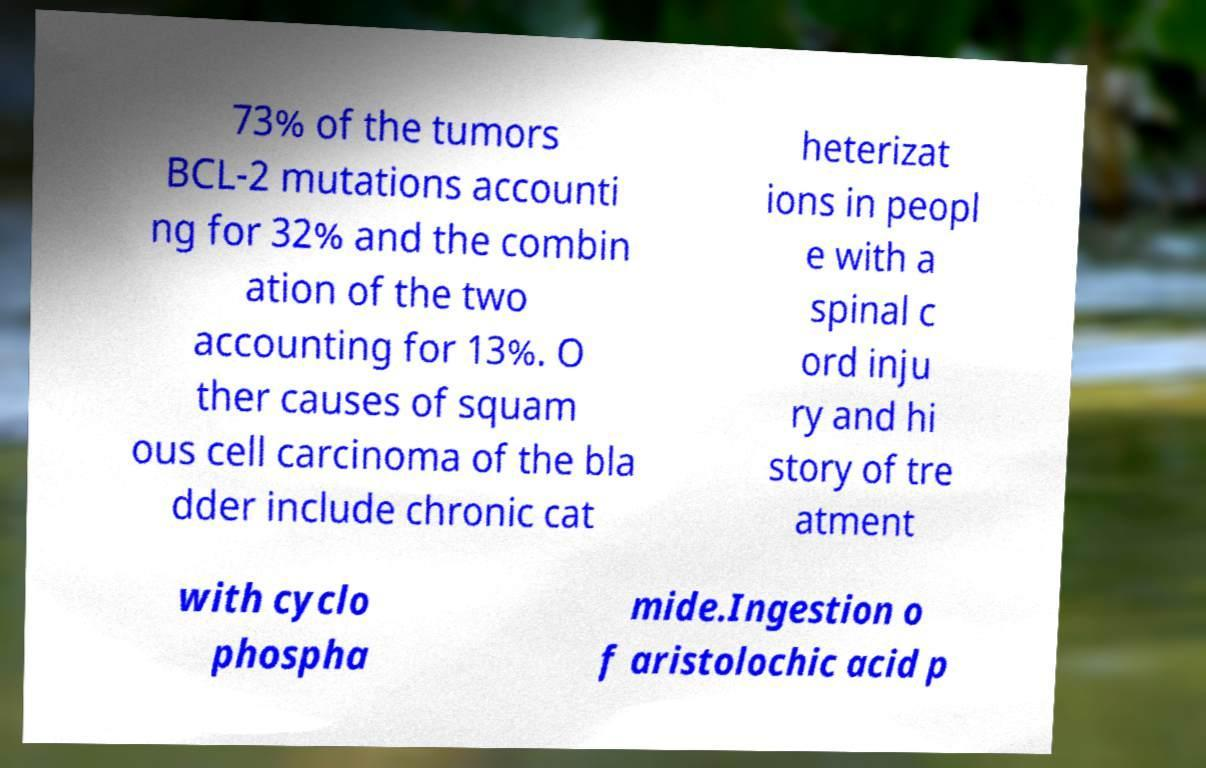Can you read and provide the text displayed in the image?This photo seems to have some interesting text. Can you extract and type it out for me? 73% of the tumors BCL-2 mutations accounti ng for 32% and the combin ation of the two accounting for 13%. O ther causes of squam ous cell carcinoma of the bla dder include chronic cat heterizat ions in peopl e with a spinal c ord inju ry and hi story of tre atment with cyclo phospha mide.Ingestion o f aristolochic acid p 